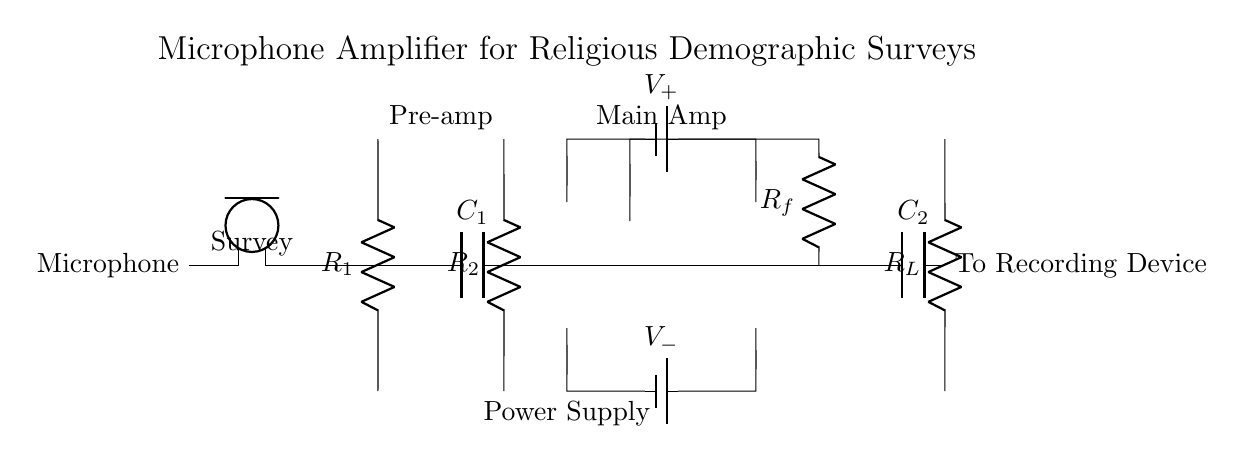What is the role of the microphone in this circuit? The microphone serves as the input device that captures sound waves and converts them into an electrical signal for amplification.
Answer: Input device What component provides the gain in the circuit? The operational amplifier, or op amp, amplifies the weak electrical signal from the microphone to a stronger output signal.
Answer: Operational amplifier What is the function of the capacitor labeled C1? The capacitor C1 is filtering the signal to block DC components while allowing AC components (the audio signals) to pass through.
Answer: Filtering How many resistors are present in the amplifier circuit? There are three resistors (R1, R2, and Rf) in the circuit that influence the gain and stability of the amplification.
Answer: Three What is the connection of the power supply to the operational amplifier? The power supply is connected with V- to the negative terminal and V+ to the positive terminal of the operational amplifier, ensuring it operates correctly.
Answer: Dual supply How does the feedback resistor Rf affect the circuit's gain? The feedback resistor Rf determines the gain of the operational amplifier by creating a feedback loop that stabilizes and sets the level of amplification based on its value relative to R1.
Answer: Sets gain Where does the output of the amplifier go in this circuit? The output from the amplifier is directed towards a recording device, allowing the amplified audio signal to be captured for further analysis or recording.
Answer: To recording device 